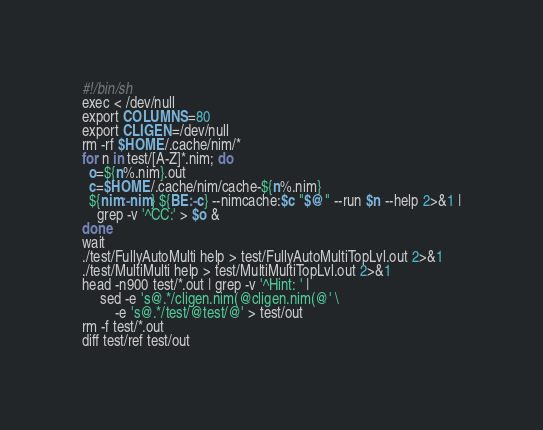<code> <loc_0><loc_0><loc_500><loc_500><_Bash_>#!/bin/sh
exec < /dev/null
export COLUMNS=80
export CLIGEN=/dev/null
rm -rf $HOME/.cache/nim/*
for n in test/[A-Z]*.nim; do
  o=${n%.nim}.out
  c=$HOME/.cache/nim/cache-${n%.nim}
  ${nim:-nim} ${BE:-c} --nimcache:$c "$@" --run $n --help 2>&1 |
    grep -v '^CC:' > $o &
done
wait
./test/FullyAutoMulti help > test/FullyAutoMultiTopLvl.out 2>&1
./test/MultiMulti help > test/MultiMultiTopLvl.out 2>&1
head -n900 test/*.out | grep -v '^Hint: ' |
     sed -e 's@.*/cligen.nim(@cligen.nim(@' \
         -e 's@.*/test/@test/@' > test/out
rm -f test/*.out
diff test/ref test/out
</code> 